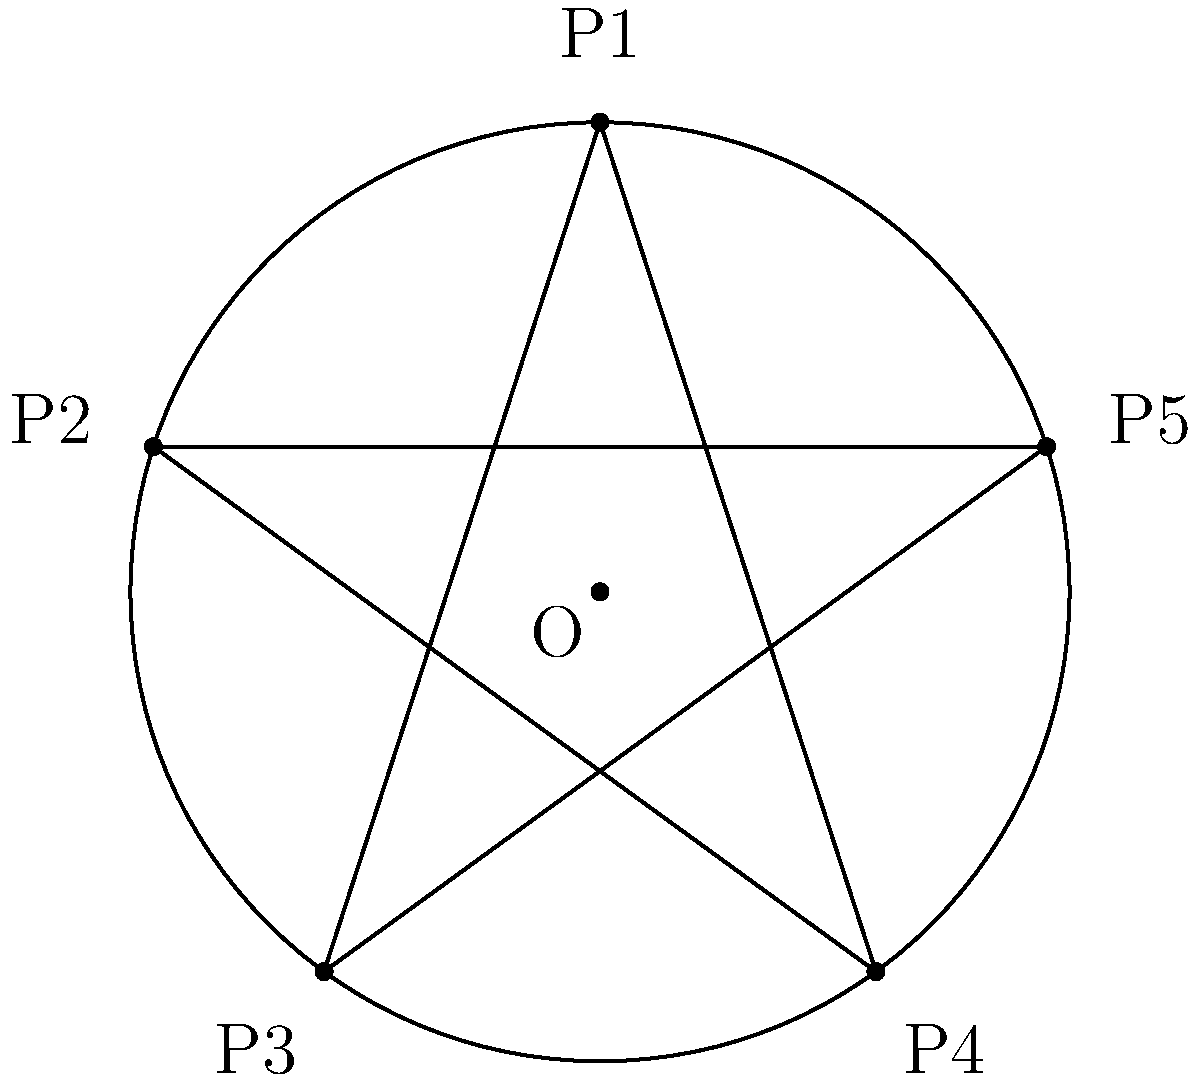In the dark recesses of an ancient tome, you discover a diagram of a pentagram inscribed within a circle, reminiscent of occult symbols. The circle has a radius of 5 units. Calculate the area of the pentagram, assuming it is regular and its vertices touch the circle. Express your answer in terms of $\pi$. To find the area of the pentagram, we'll follow these haunting steps:

1) First, we need to find the area of the regular pentagon formed by connecting the vertices of the pentagram.

2) The central angle of a regular pentagon is $\frac{360°}{5} = 72°$.

3) The area of the pentagon can be calculated using the formula:
   $$A_{pentagon} = \frac{5r^2}{4}\sin(72°)$$
   where $r$ is the radius of the circumscribed circle.

4) Substituting $r = 5$:
   $$A_{pentagon} = \frac{5(5^2)}{4}\sin(72°) = \frac{125}{4}\sin(72°)$$

5) Now, we need to subtract the area of the five triangles formed in the pentagram.

6) Each of these triangles has a base equal to the side of the pentagon and a height that can be calculated.

7) The side length of the pentagon is $s = 2r\sin(36°) = 10\sin(36°)$.

8) The height of each triangle is $h = r - r\cos(36°) = 5 - 5\cos(36°)$.

9) The area of each triangle is:
   $$A_{triangle} = \frac{1}{2} \cdot 10\sin(36°) \cdot 5(1-\cos(36°))$$

10) The total area to subtract is $5A_{triangle}$.

11) Therefore, the area of the pentagram is:
    $$A_{pentagram} = A_{pentagon} - 5A_{triangle}$$
    $$= \frac{125}{4}\sin(72°) - 25\sin(36°)(1-\cos(36°))$$

12) This can be simplified to approximately $11.756$ square units.

13) To express in terms of $\pi$, we can divide by $\pi$ and multiply:
    $$A_{pentagram} \approx 3.74\pi$$ square units.
Answer: $3.74\pi$ square units 